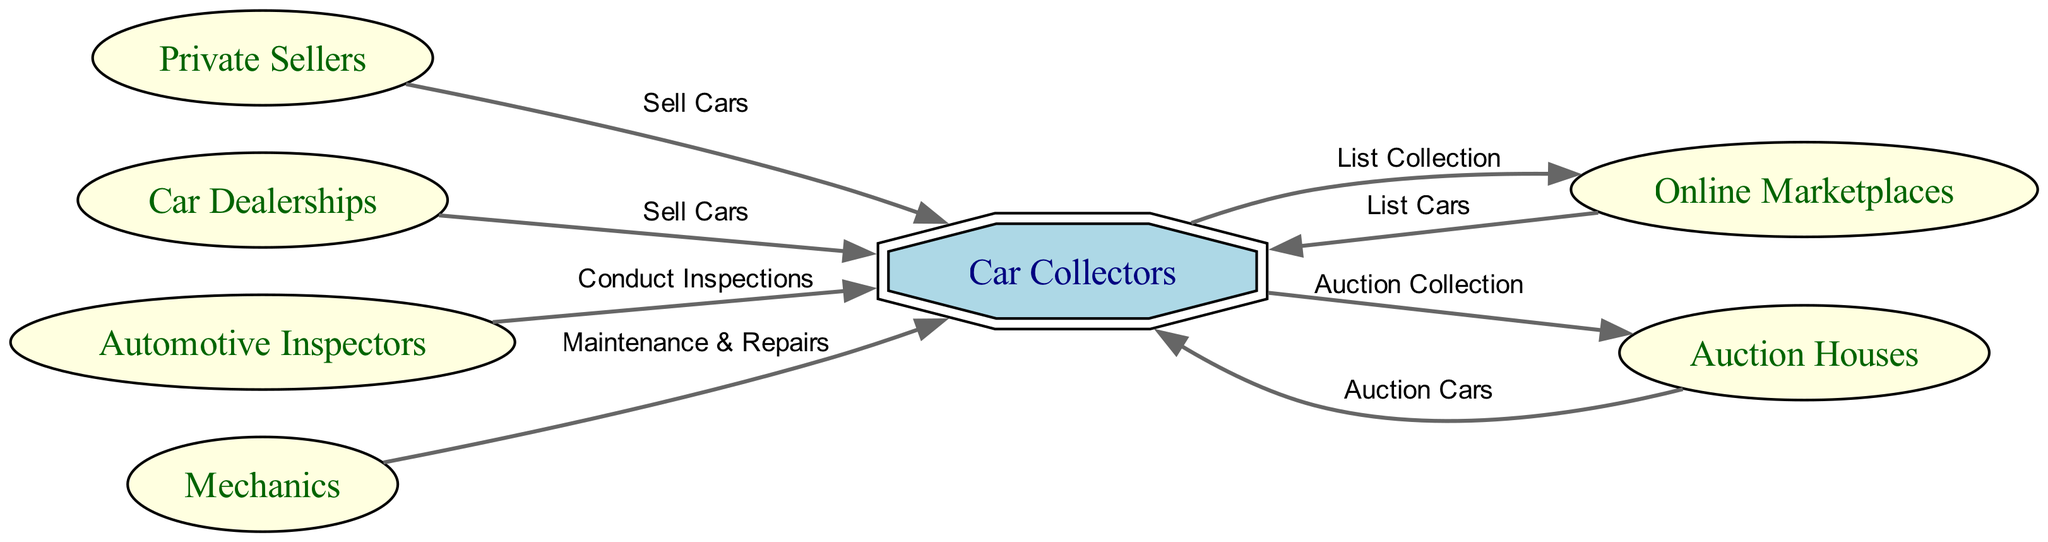What is the total number of nodes in the diagram? The diagram contains nodes for car collectors, private sellers, car dealerships, online marketplaces, auction houses, automotive inspectors, and mechanics. Counting these gives a total of 7 nodes.
Answer: 7 Which node is responsible for conducting inspections? The diagram shows that automotive inspectors have a directed edge labeled "Conduct Inspections" pointing to car collectors. This indicates that they are responsible for performing inspections.
Answer: Automotive Inspectors Who sells cars to car collectors? According to the edges in the diagram, both private sellers and car dealerships have directed edges labeled "Sell Cars" pointing to car collectors, indicating they sell cars to them.
Answer: Private Sellers and Car Dealerships How many different roles interact with car collectors? Car collectors interact with private sellers, car dealerships, online marketplaces, auction houses, automotive inspectors, and mechanics, which totals to 6 different roles.
Answer: 6 What is one way car collectors interact with online marketplaces? The edge labeled "List Collection" going from car collectors to online marketplaces shows that car collectors interact with online marketplaces by listing their car collection.
Answer: List Collection Which two players are involved in both selling and auctioning cars? The diagram indicates that both car dealerships and private sellers sell cars to car collectors, while auction houses auction cars to car collectors. Since both categories involve the act of either selling or auctioning cars, these three players feature prominently in both activities.
Answer: Private Sellers and Car Dealerships What type of interactions can car collectors have with mechanics? The edge labeled "Maintenance & Repairs" from mechanics to car collectors implies that car collectors can seek maintenance and repair services from mechanics.
Answer: Maintenance & Repairs How many edges are directed towards car collectors? Upon examining the edges, we find that there are multiple directions: private sellers, car dealerships, online marketplaces, auction houses, automotive inspectors, and mechanics all have directed edges leading to car collectors, giving a total of 6 edges directed towards car collectors.
Answer: 6 What unique feature distinguishes car collectors from other nodes? Car collectors are highlighted with a doubleoctagon shape and filled with light blue color, which signifies a unique feature distinguishing them from other nodes represented as ellipses.
Answer: Doubleoctagon shape 